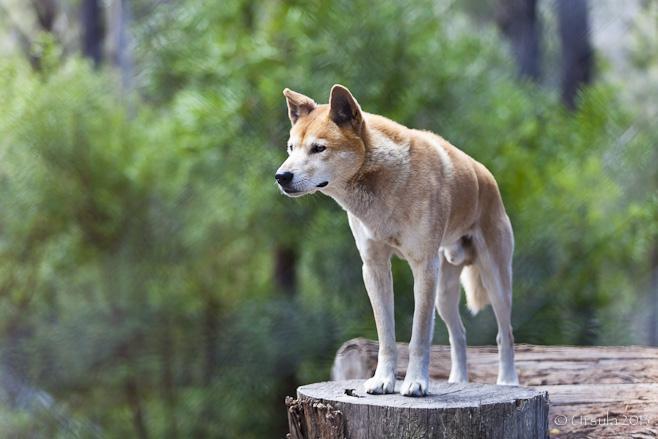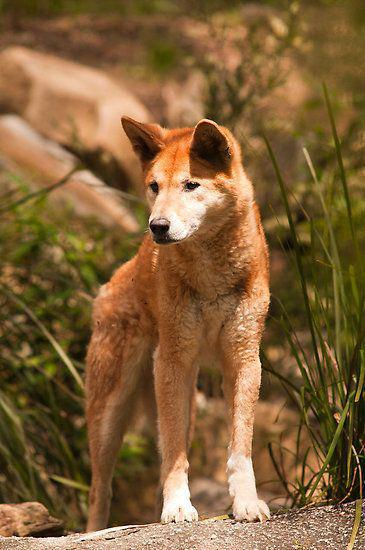The first image is the image on the left, the second image is the image on the right. Evaluate the accuracy of this statement regarding the images: "There is at most 2 dingoes.". Is it true? Answer yes or no. Yes. The first image is the image on the left, the second image is the image on the right. Given the left and right images, does the statement "One dog is touching another dogs chin with its head." hold true? Answer yes or no. No. 